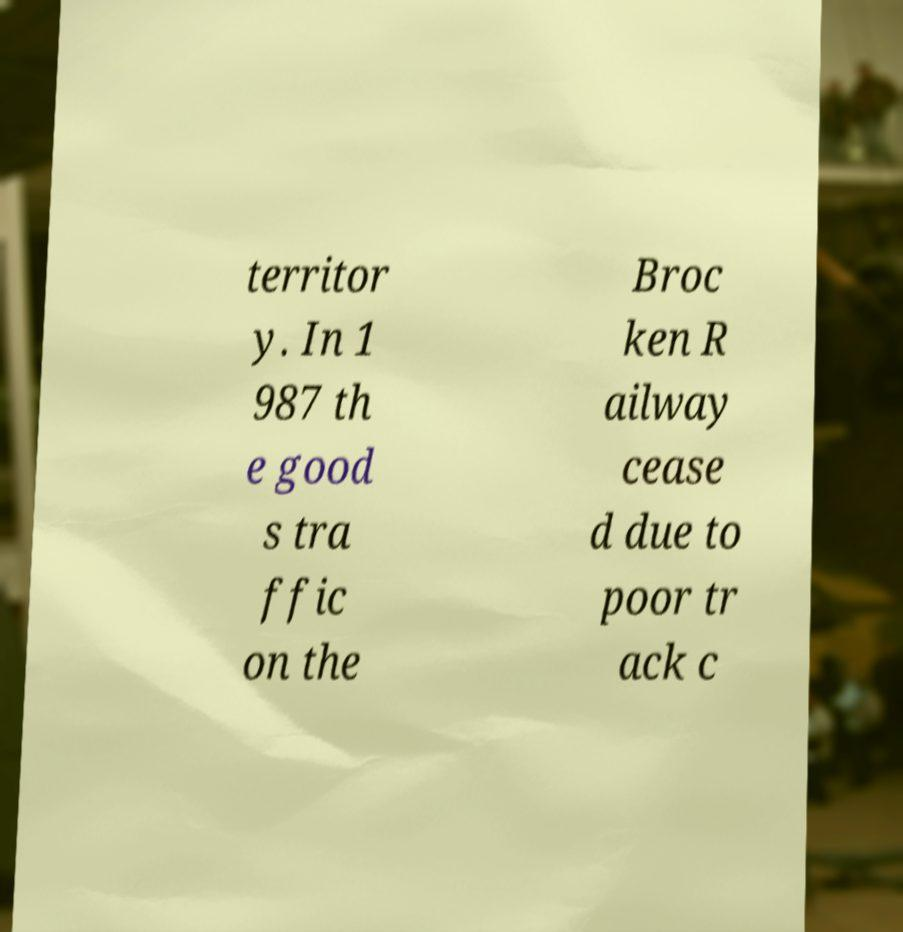Can you read and provide the text displayed in the image?This photo seems to have some interesting text. Can you extract and type it out for me? territor y. In 1 987 th e good s tra ffic on the Broc ken R ailway cease d due to poor tr ack c 